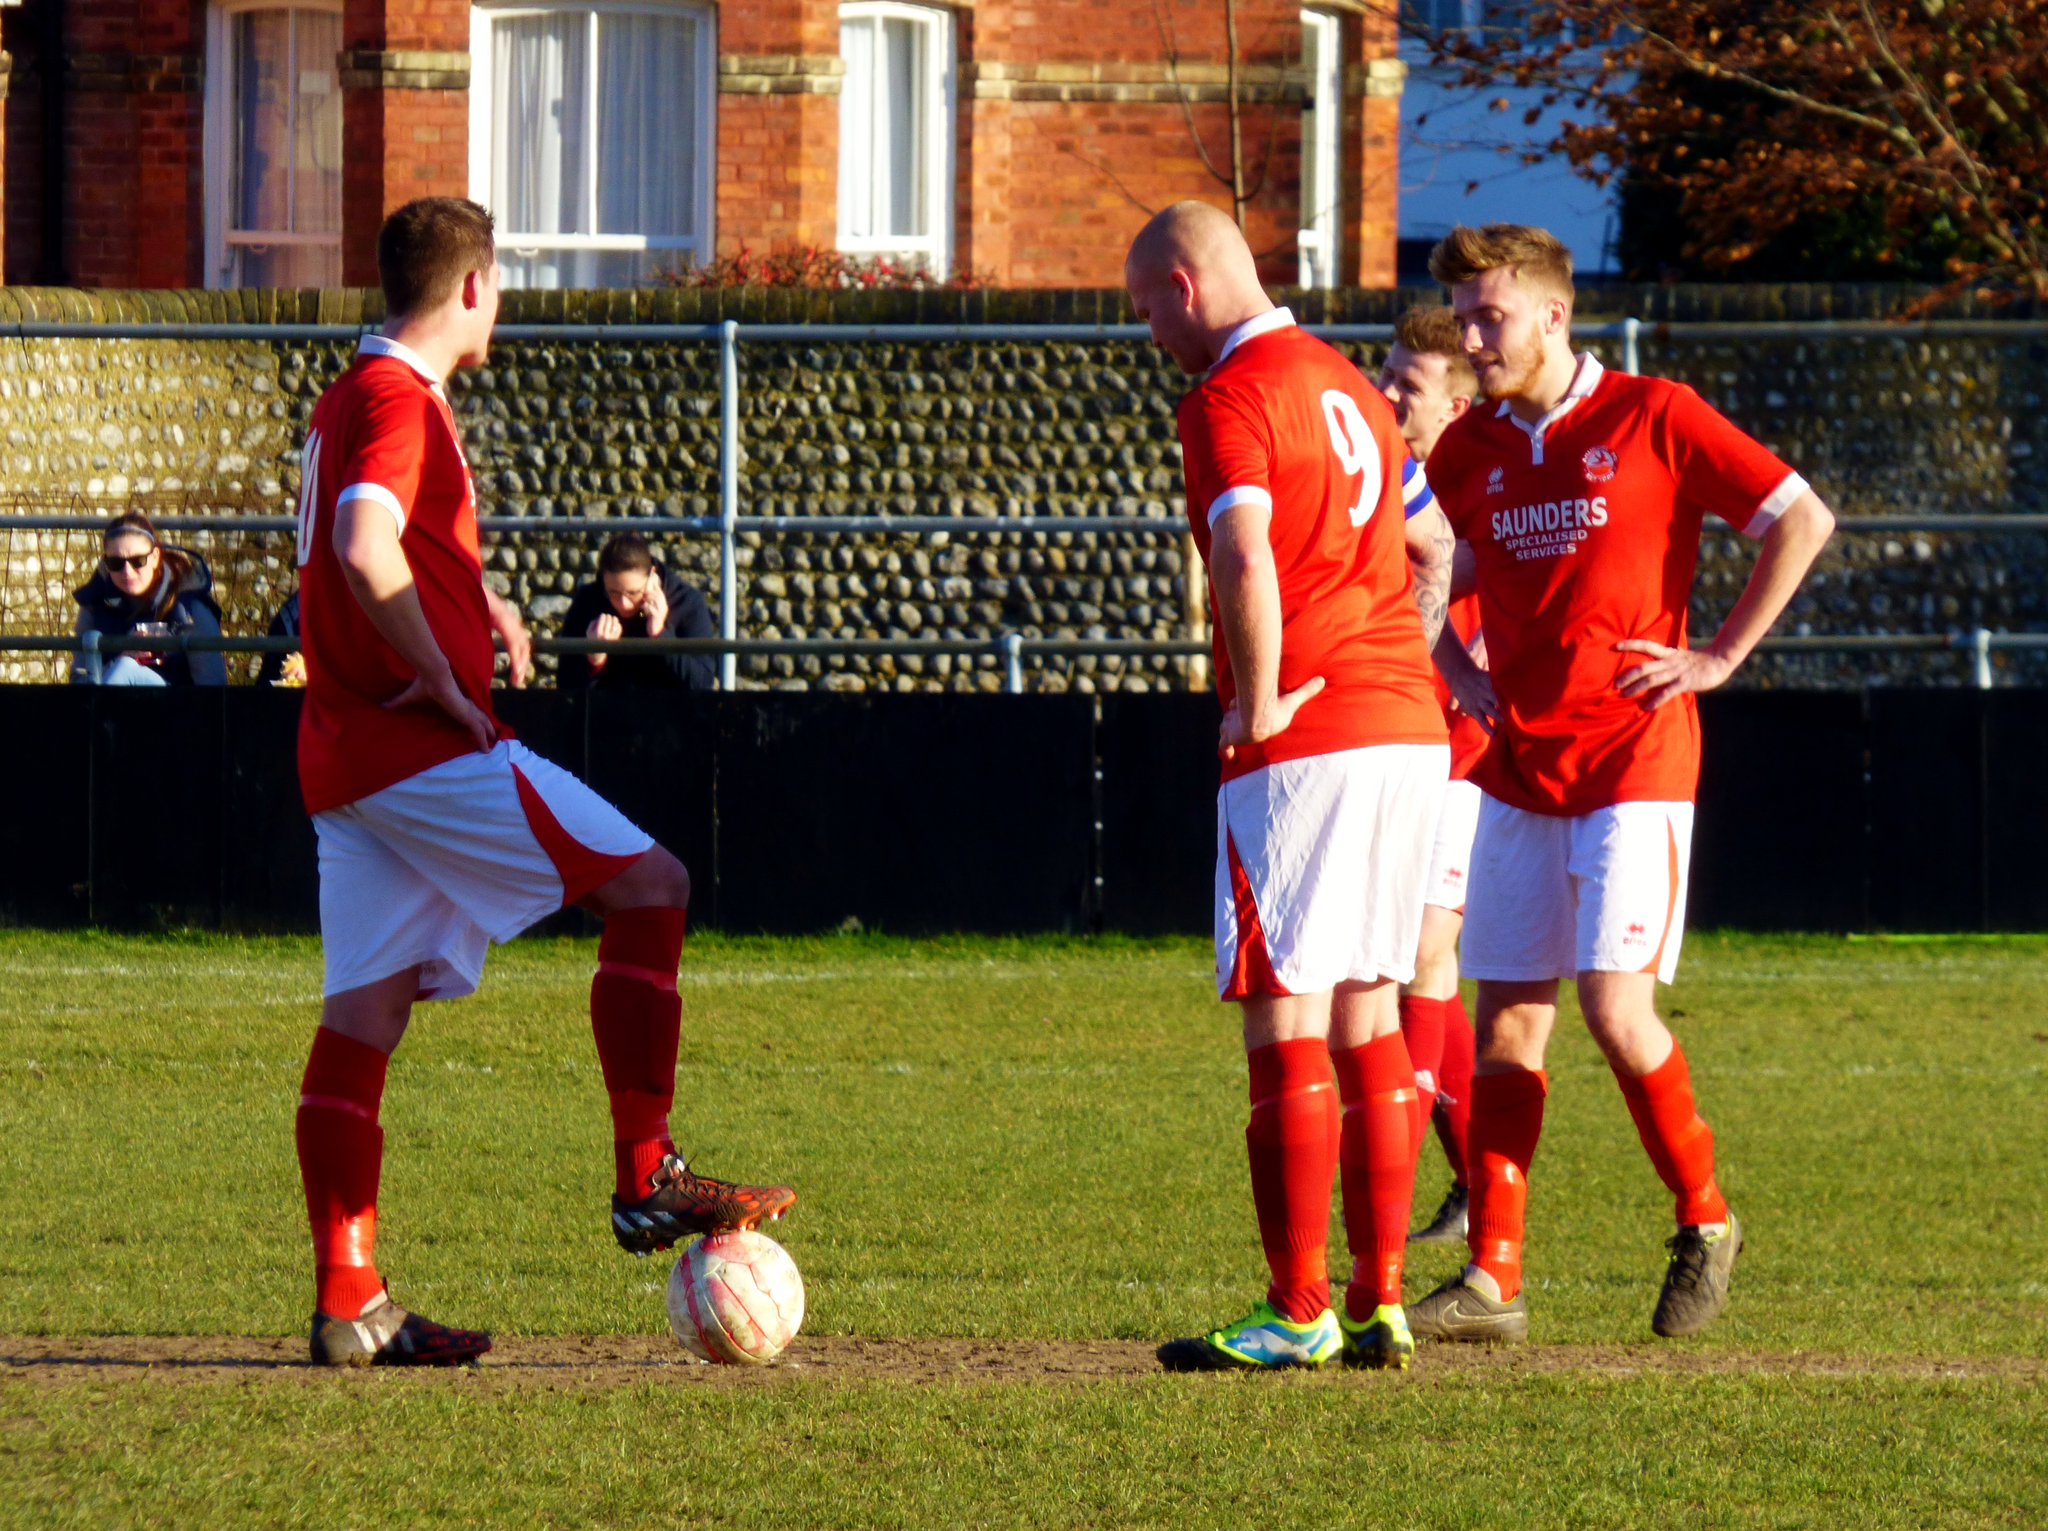Provide a one-sentence caption for the provided image. A group of male soccer players standing together on the field wearing orange and white shirts with sponsor, Saunders Specialized Services, printed on the front. 